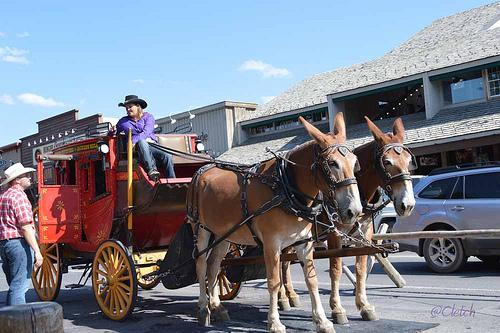Question: who is in the photo?
Choices:
A. Two dogs and a cat.
B. Men.
C. Three women.
D. Five little girls.
Answer with the letter. Answer: B Question: why is the photo clear?
Choices:
A. Expensive lens.
B. Photographer used a tripod.
C. High-quality film stock.
D. It's during the day.
Answer with the letter. Answer: D Question: how is the photo?
Choices:
A. Blurry.
B. Clear.
C. Overexposed.
D. Underexposed.
Answer with the letter. Answer: B Question: where was the photo taken?
Choices:
A. On the street.
B. On the dirt road.
C. On the sidewalk.
D. By grass.
Answer with the letter. Answer: A 